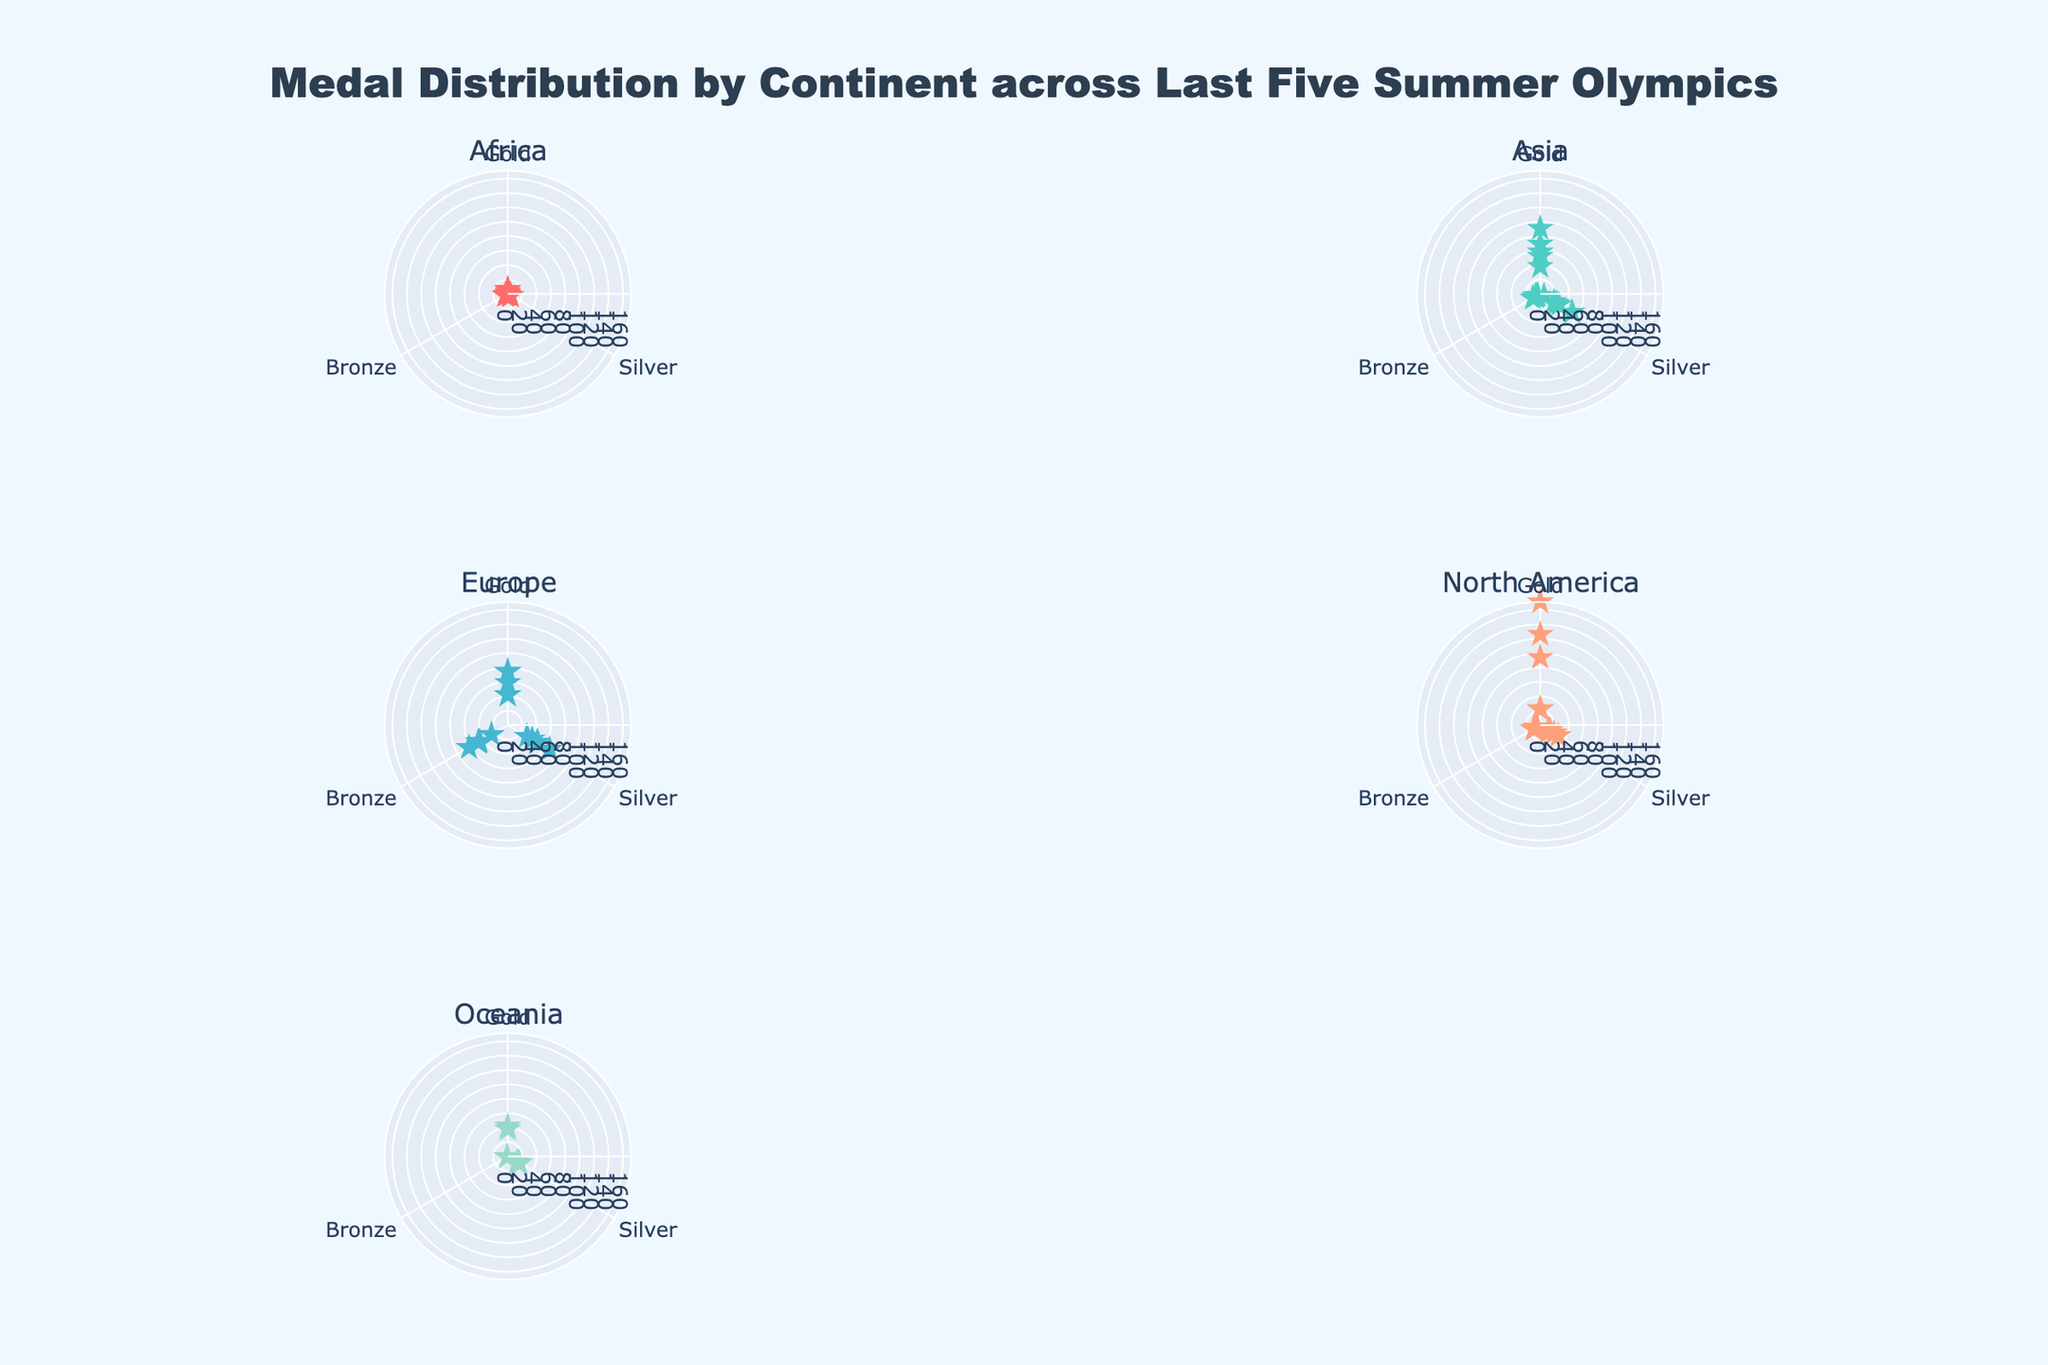Which continent has the highest count of gold medals? By observing the radial distribution in the polar plots, North America (particularly the United States) has the highest number of gold medals represented by its broader spread in the 'Gold' partition of the plot.
Answer: North America How many total bronze medals does Europe have? Summing the bronze medals of all European countries in the plot: 59 (United Kingdom) + 48 (Germany) + 47 (France) + 62 (Russia) + 47 (Italy) gives a total of 263.
Answer: 263 Which country in Oceania has the least number of medals? From the plot, Fiji has the least medals in Oceania, with its single data point for each medal type positioned much closer to the center compared to other countries like Australia and New Zealand.
Answer: Fiji Compare the total number of medals (gold, silver, bronze) between Asia and Africa. Which has more? Summing the total medals for each region: Asia: (91+69+52) China + (58+38+51) Japan + (30+26+22) South Korea + (6+6+8) India + (12+4+8) Kazakhstan = 552. Africa: (6+6+1) Kenya + (6+3+5) South Africa + (4+4+1) Ethiopia + (0+2+2) Nigeria + (1+3+4) Egypt = 48. Asia has more total medals.
Answer: Asia What is the median value of silver medals count for countries in North America? Listing the silver medal counts for North American countries: 126 (USA), 22 (Canada), 14 (Cuba), 6 (Jamaica), 9 (Mexico). Ordering them: 6, 9, 14, 22, 126, the median value is the middle number, which is 14.
Answer: 14 Which continents have fewer than 10 data points in total? The number of unique countries (data points) from Africa (5) and Oceania (3) is fewer than 10, as indicated by the number of distinct markers in those continent-specific plots.
Answer: Africa and Oceania What is the average number of gold medals won by South American countries in the last five Olympics? Considering that the data does not include any South American countries, the average calculation is not applicable here. South American countries are not represented in the current dataset.
Answer: Not applicable (no data) Which European country has won the most silver medals? Observing the European segment in the plot, Italy has the largest spread in the 'Silver' partition, indicating it has won the most silver medals among European countries.
Answer: Italy By what percentage did the total gold medals in Asia differ from the total gold medals in Africa? Asia: 91 (China) + 58 (Japan) + 30 (South Korea) + 6 (India) + 12 (Kazakhstan) = 197. Africa: 6 (Kenya) + 6 (South Africa) + 4 (Ethiopia) + 0 (Nigeria) + 1 (Egypt) = 17. Percentage difference = ((197 - 17)/17) * 100% = 1058.82%.
Answer: 1058.82% Which North American country has the highest discrepancy between its gold and bronze medal counts? Reviewing the plot for North America, the United States shows the largest gap between its gold (171) and bronze (94) counts, with a difference of 77.
Answer: United States 